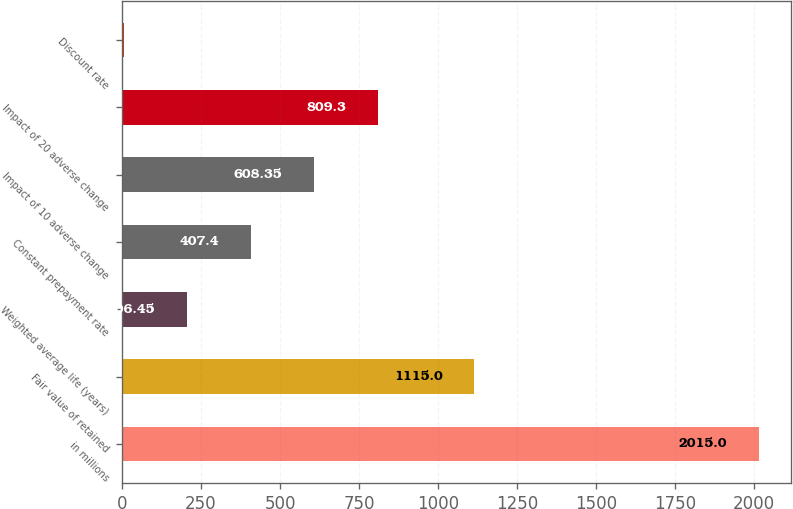Convert chart. <chart><loc_0><loc_0><loc_500><loc_500><bar_chart><fcel>in millions<fcel>Fair value of retained<fcel>Weighted average life (years)<fcel>Constant prepayment rate<fcel>Impact of 10 adverse change<fcel>Impact of 20 adverse change<fcel>Discount rate<nl><fcel>2015<fcel>1115<fcel>206.45<fcel>407.4<fcel>608.35<fcel>809.3<fcel>5.5<nl></chart> 